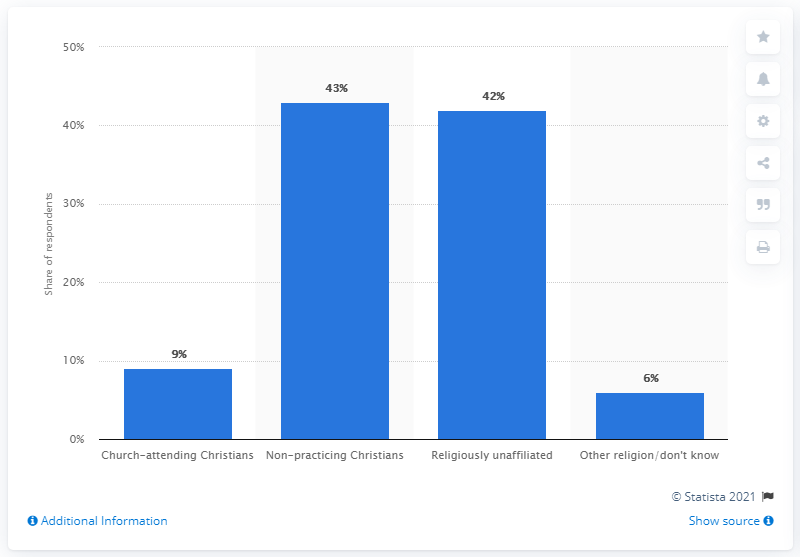Indicate a few pertinent items in this graphic. According to a survey, 43% of the Swedish population identified themselves as non-practicing Christians. 